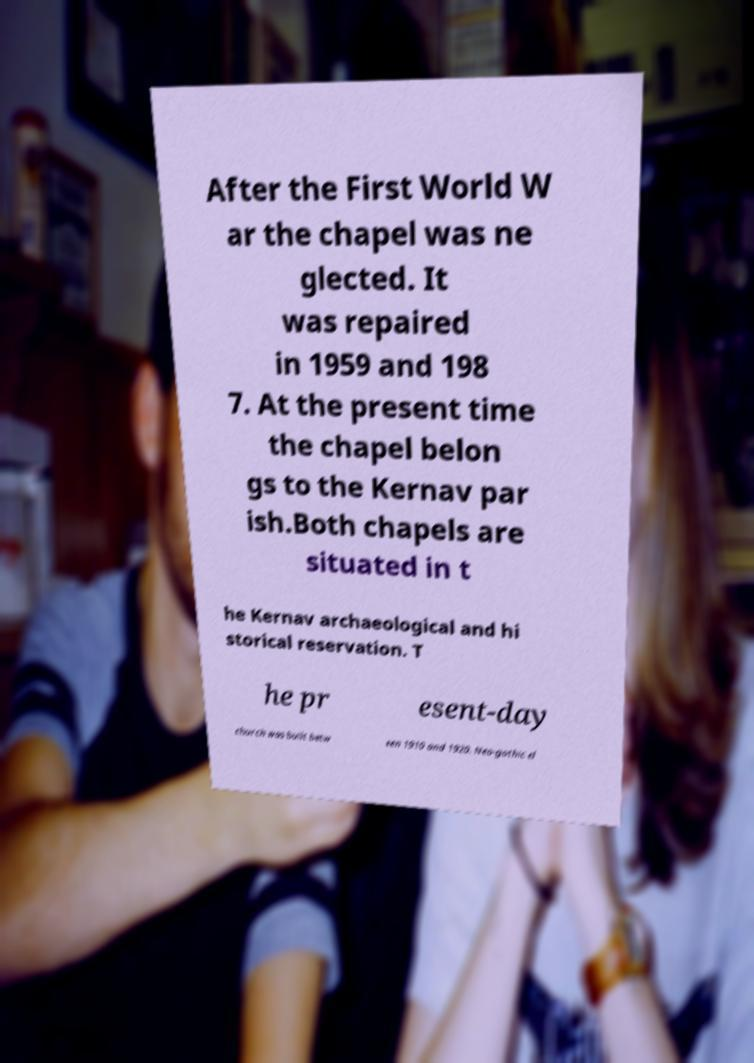Can you accurately transcribe the text from the provided image for me? After the First World W ar the chapel was ne glected. It was repaired in 1959 and 198 7. At the present time the chapel belon gs to the Kernav par ish.Both chapels are situated in t he Kernav archaeological and hi storical reservation. T he pr esent-day church was built betw een 1910 and 1920. Neo-gothic el 